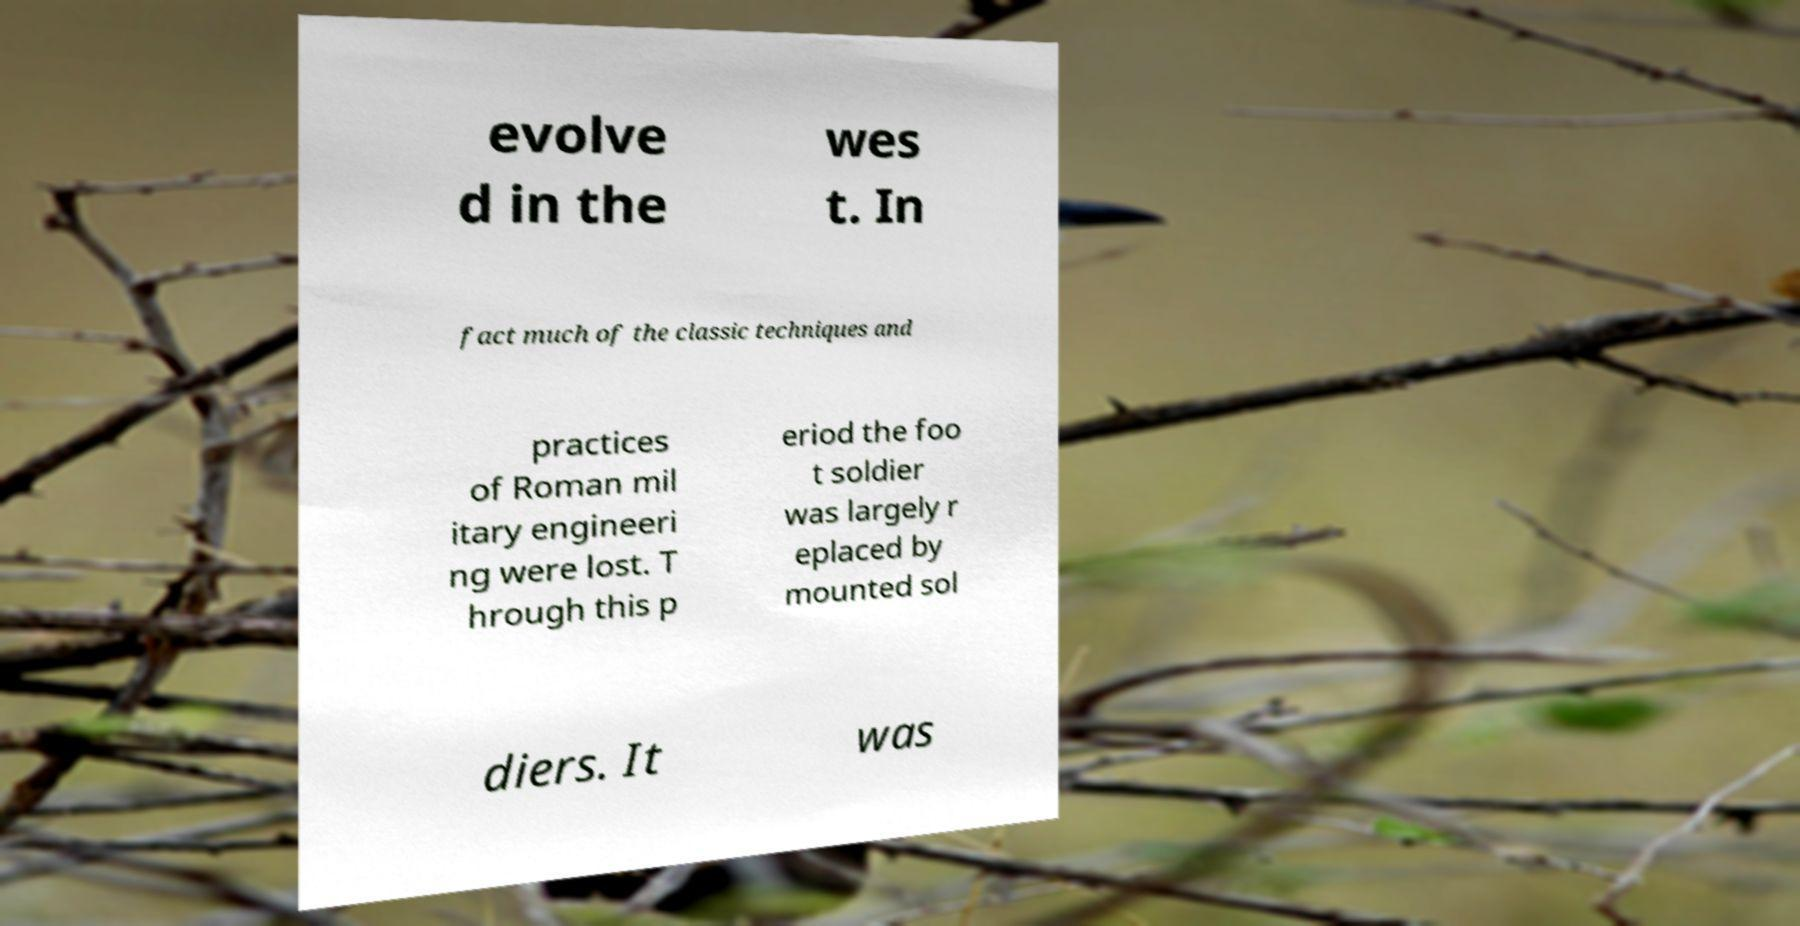Could you extract and type out the text from this image? evolve d in the wes t. In fact much of the classic techniques and practices of Roman mil itary engineeri ng were lost. T hrough this p eriod the foo t soldier was largely r eplaced by mounted sol diers. It was 